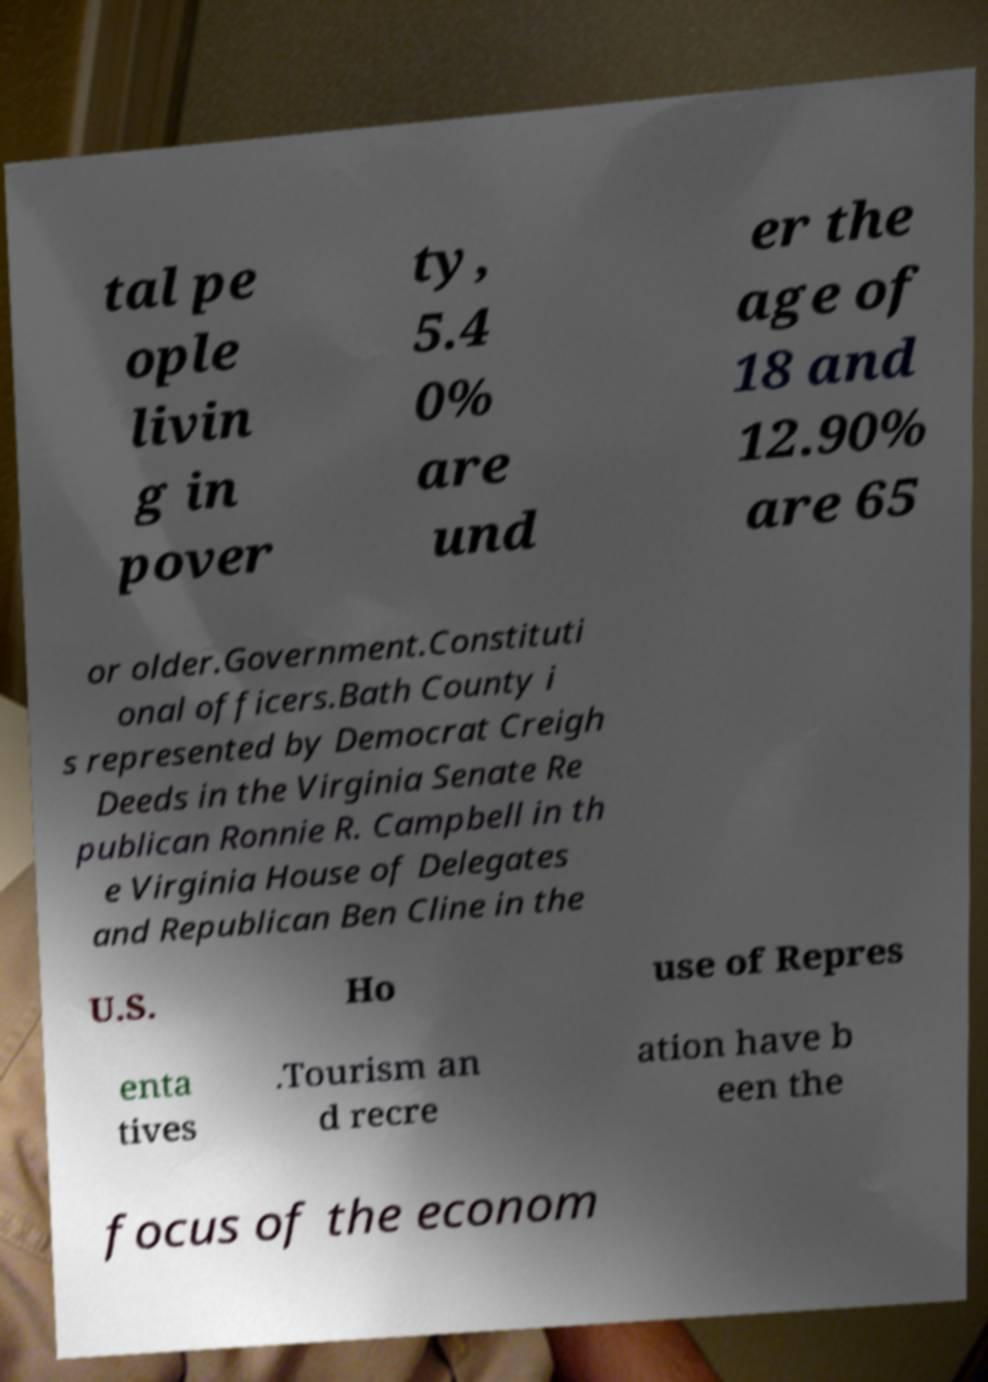Can you read and provide the text displayed in the image?This photo seems to have some interesting text. Can you extract and type it out for me? tal pe ople livin g in pover ty, 5.4 0% are und er the age of 18 and 12.90% are 65 or older.Government.Constituti onal officers.Bath County i s represented by Democrat Creigh Deeds in the Virginia Senate Re publican Ronnie R. Campbell in th e Virginia House of Delegates and Republican Ben Cline in the U.S. Ho use of Repres enta tives .Tourism an d recre ation have b een the focus of the econom 